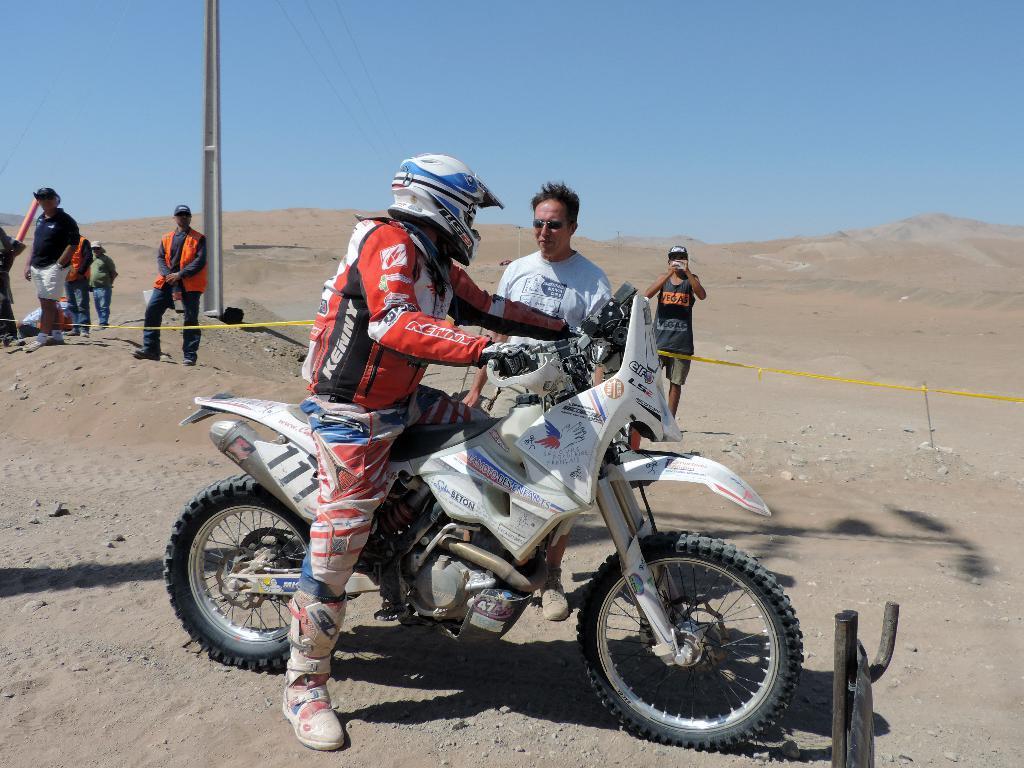In one or two sentences, can you explain what this image depicts? As we can see in the image there are few people here and there, motorcycle and sky. 